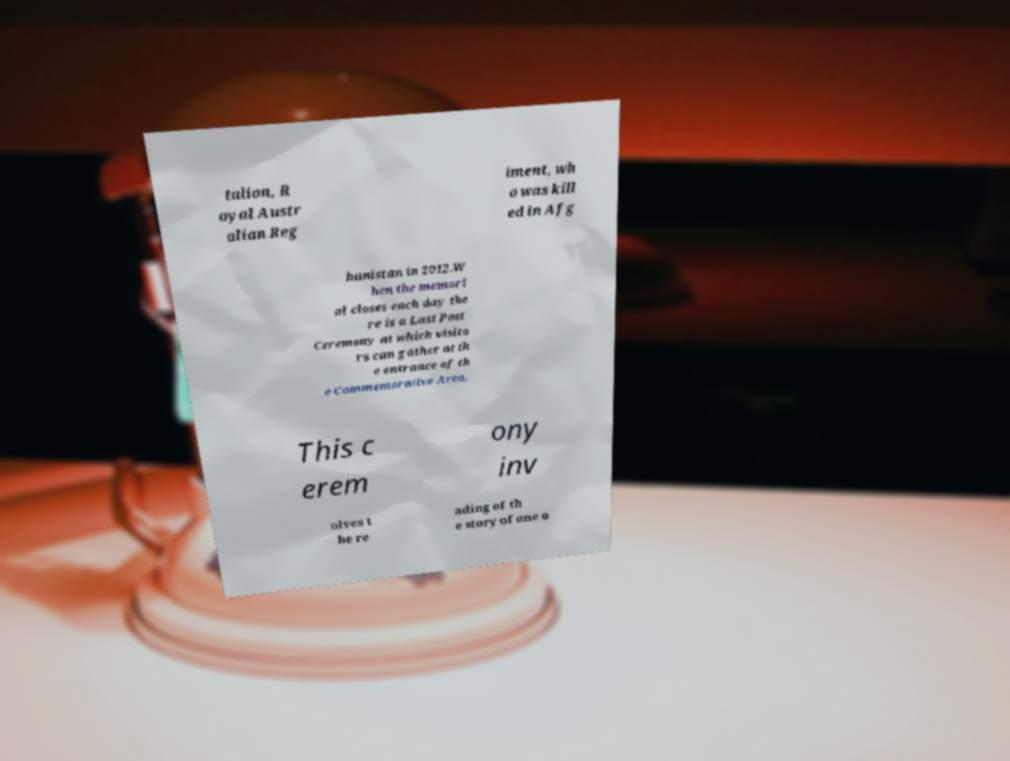Please identify and transcribe the text found in this image. talion, R oyal Austr alian Reg iment, wh o was kill ed in Afg hanistan in 2012.W hen the memori al closes each day the re is a Last Post Ceremony at which visito rs can gather at th e entrance of th e Commemorative Area. This c erem ony inv olves t he re ading of th e story of one o 